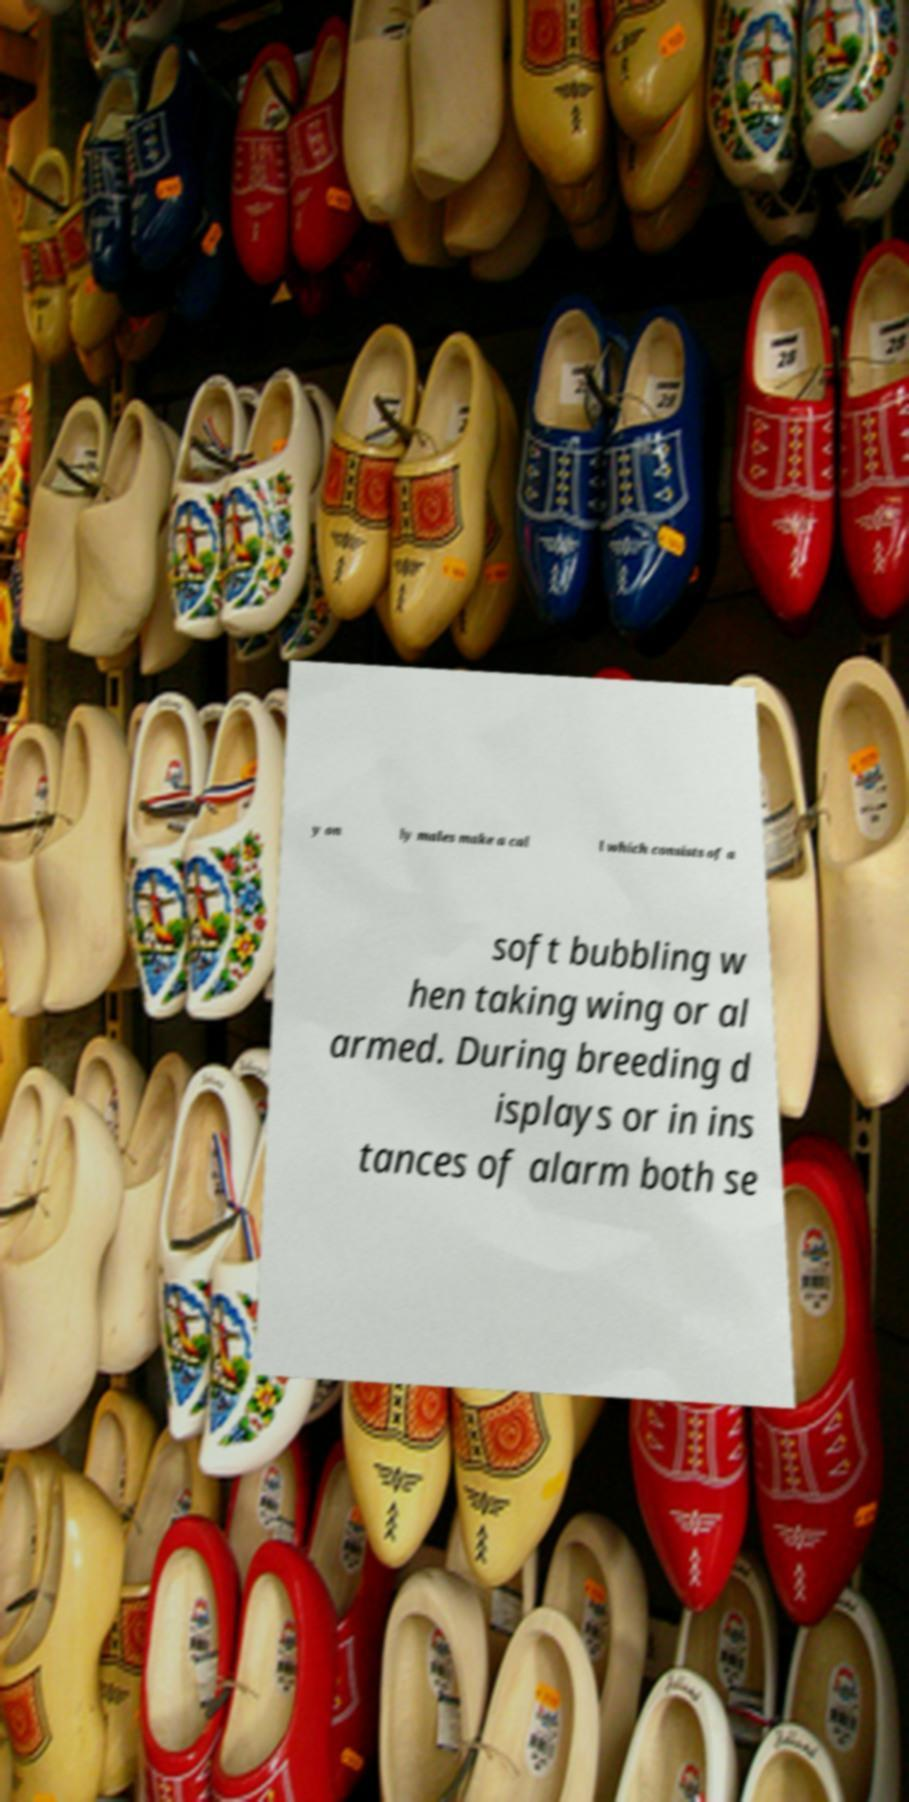There's text embedded in this image that I need extracted. Can you transcribe it verbatim? y on ly males make a cal l which consists of a soft bubbling w hen taking wing or al armed. During breeding d isplays or in ins tances of alarm both se 